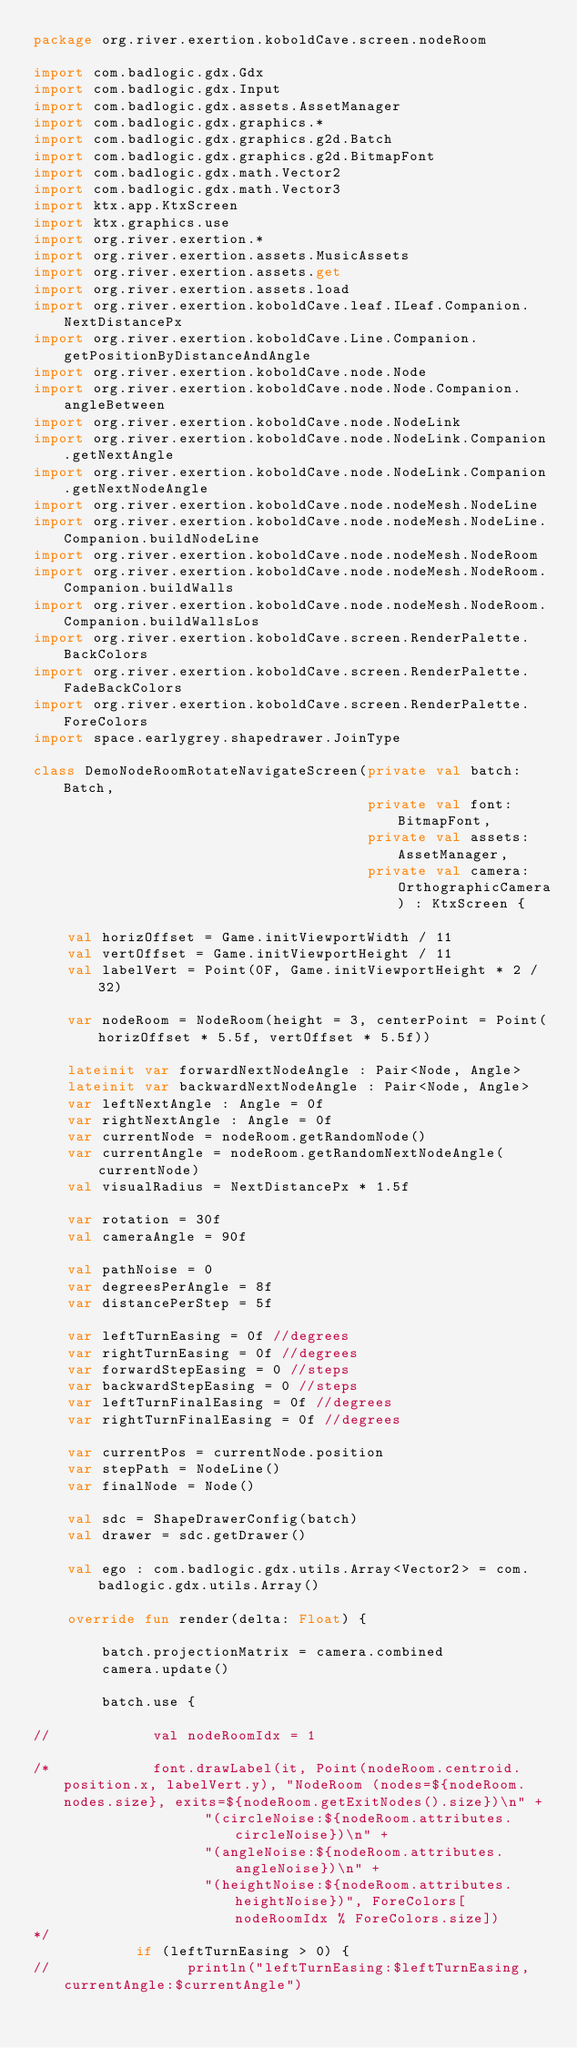Convert code to text. <code><loc_0><loc_0><loc_500><loc_500><_Kotlin_>package org.river.exertion.koboldCave.screen.nodeRoom

import com.badlogic.gdx.Gdx
import com.badlogic.gdx.Input
import com.badlogic.gdx.assets.AssetManager
import com.badlogic.gdx.graphics.*
import com.badlogic.gdx.graphics.g2d.Batch
import com.badlogic.gdx.graphics.g2d.BitmapFont
import com.badlogic.gdx.math.Vector2
import com.badlogic.gdx.math.Vector3
import ktx.app.KtxScreen
import ktx.graphics.use
import org.river.exertion.*
import org.river.exertion.assets.MusicAssets
import org.river.exertion.assets.get
import org.river.exertion.assets.load
import org.river.exertion.koboldCave.leaf.ILeaf.Companion.NextDistancePx
import org.river.exertion.koboldCave.Line.Companion.getPositionByDistanceAndAngle
import org.river.exertion.koboldCave.node.Node
import org.river.exertion.koboldCave.node.Node.Companion.angleBetween
import org.river.exertion.koboldCave.node.NodeLink
import org.river.exertion.koboldCave.node.NodeLink.Companion.getNextAngle
import org.river.exertion.koboldCave.node.NodeLink.Companion.getNextNodeAngle
import org.river.exertion.koboldCave.node.nodeMesh.NodeLine
import org.river.exertion.koboldCave.node.nodeMesh.NodeLine.Companion.buildNodeLine
import org.river.exertion.koboldCave.node.nodeMesh.NodeRoom
import org.river.exertion.koboldCave.node.nodeMesh.NodeRoom.Companion.buildWalls
import org.river.exertion.koboldCave.node.nodeMesh.NodeRoom.Companion.buildWallsLos
import org.river.exertion.koboldCave.screen.RenderPalette.BackColors
import org.river.exertion.koboldCave.screen.RenderPalette.FadeBackColors
import org.river.exertion.koboldCave.screen.RenderPalette.ForeColors
import space.earlygrey.shapedrawer.JoinType

class DemoNodeRoomRotateNavigateScreen(private val batch: Batch,
                                       private val font: BitmapFont,
                                       private val assets: AssetManager,
                                       private val camera: OrthographicCamera) : KtxScreen {

    val horizOffset = Game.initViewportWidth / 11
    val vertOffset = Game.initViewportHeight / 11
    val labelVert = Point(0F, Game.initViewportHeight * 2 / 32)

    var nodeRoom = NodeRoom(height = 3, centerPoint = Point(horizOffset * 5.5f, vertOffset * 5.5f))

    lateinit var forwardNextNodeAngle : Pair<Node, Angle>
    lateinit var backwardNextNodeAngle : Pair<Node, Angle>
    var leftNextAngle : Angle = 0f
    var rightNextAngle : Angle = 0f
    var currentNode = nodeRoom.getRandomNode()
    var currentAngle = nodeRoom.getRandomNextNodeAngle(currentNode)
    val visualRadius = NextDistancePx * 1.5f

    var rotation = 30f
    val cameraAngle = 90f

    val pathNoise = 0
    var degreesPerAngle = 8f
    var distancePerStep = 5f

    var leftTurnEasing = 0f //degrees
    var rightTurnEasing = 0f //degrees
    var forwardStepEasing = 0 //steps
    var backwardStepEasing = 0 //steps
    var leftTurnFinalEasing = 0f //degrees
    var rightTurnFinalEasing = 0f //degrees

    var currentPos = currentNode.position
    var stepPath = NodeLine()
    var finalNode = Node()

    val sdc = ShapeDrawerConfig(batch)
    val drawer = sdc.getDrawer()

    val ego : com.badlogic.gdx.utils.Array<Vector2> = com.badlogic.gdx.utils.Array()

    override fun render(delta: Float) {

        batch.projectionMatrix = camera.combined
        camera.update()

        batch.use {

//            val nodeRoomIdx = 1

/*            font.drawLabel(it, Point(nodeRoom.centroid.position.x, labelVert.y), "NodeRoom (nodes=${nodeRoom.nodes.size}, exits=${nodeRoom.getExitNodes().size})\n" +
                    "(circleNoise:${nodeRoom.attributes.circleNoise})\n" +
                    "(angleNoise:${nodeRoom.attributes.angleNoise})\n" +
                    "(heightNoise:${nodeRoom.attributes.heightNoise})", ForeColors[nodeRoomIdx % ForeColors.size])
*/
            if (leftTurnEasing > 0) {
//                println("leftTurnEasing:$leftTurnEasing, currentAngle:$currentAngle")</code> 